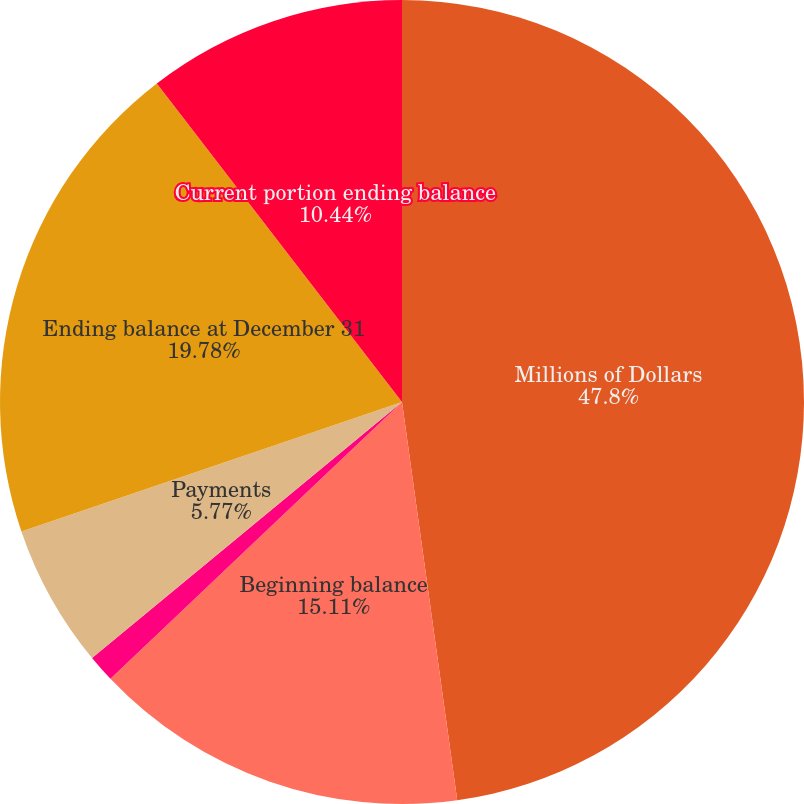<chart> <loc_0><loc_0><loc_500><loc_500><pie_chart><fcel>Millions of Dollars<fcel>Beginning balance<fcel>Accruals<fcel>Payments<fcel>Ending balance at December 31<fcel>Current portion ending balance<nl><fcel>47.81%<fcel>15.11%<fcel>1.1%<fcel>5.77%<fcel>19.78%<fcel>10.44%<nl></chart> 